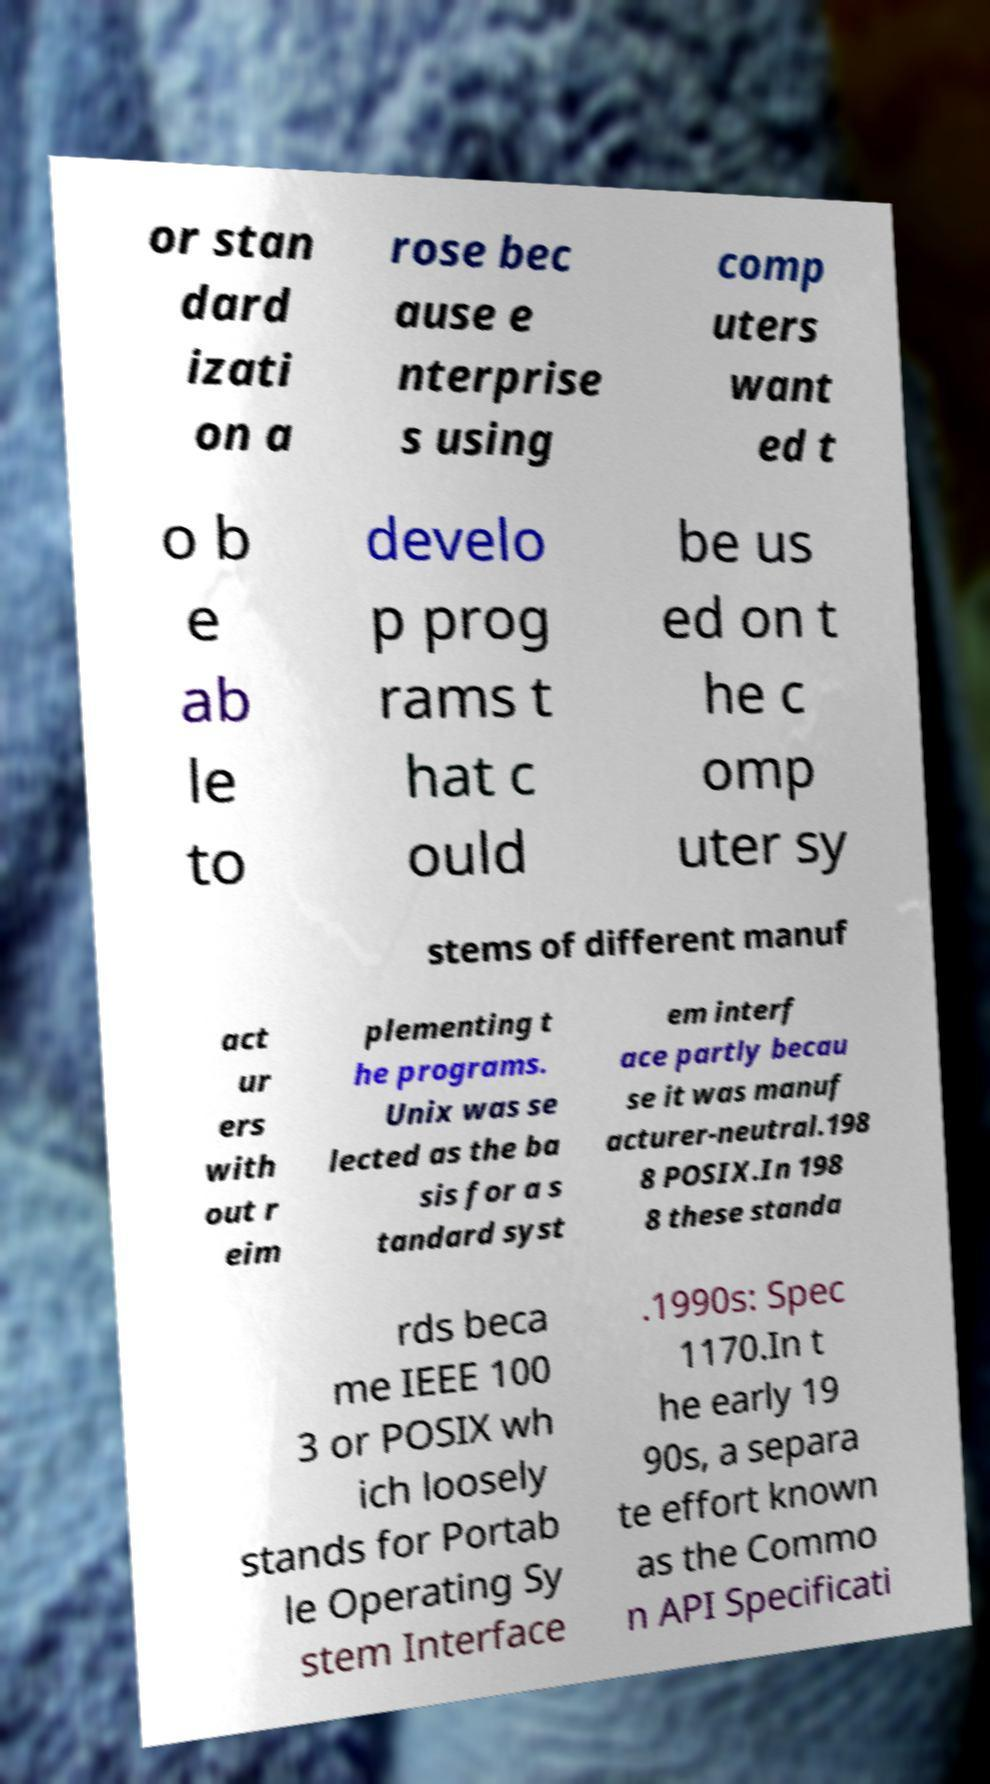Could you extract and type out the text from this image? or stan dard izati on a rose bec ause e nterprise s using comp uters want ed t o b e ab le to develo p prog rams t hat c ould be us ed on t he c omp uter sy stems of different manuf act ur ers with out r eim plementing t he programs. Unix was se lected as the ba sis for a s tandard syst em interf ace partly becau se it was manuf acturer-neutral.198 8 POSIX.In 198 8 these standa rds beca me IEEE 100 3 or POSIX wh ich loosely stands for Portab le Operating Sy stem Interface .1990s: Spec 1170.In t he early 19 90s, a separa te effort known as the Commo n API Specificati 